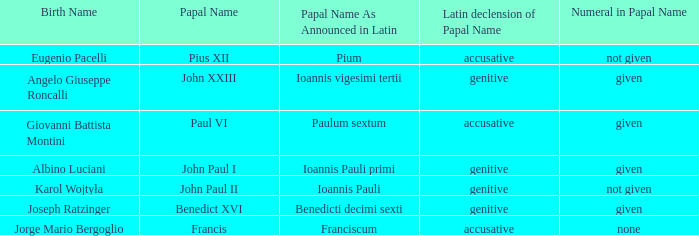What number is associated with the pope having the latin papal name of ioannis pauli? Not given. 